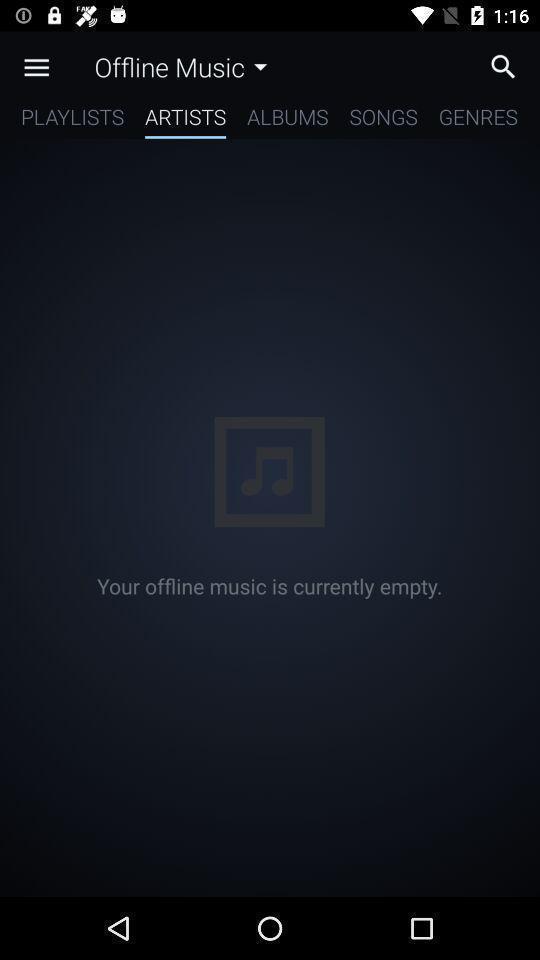Provide a detailed account of this screenshot. Window displaying the music app. 